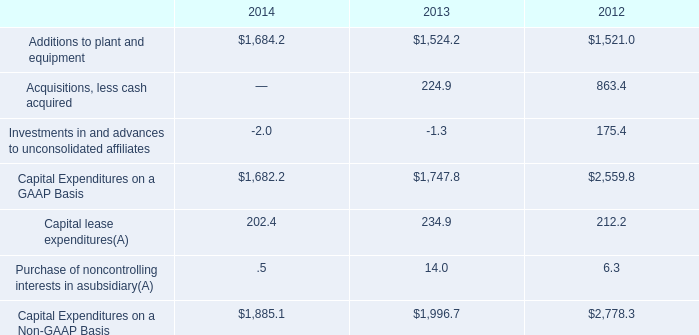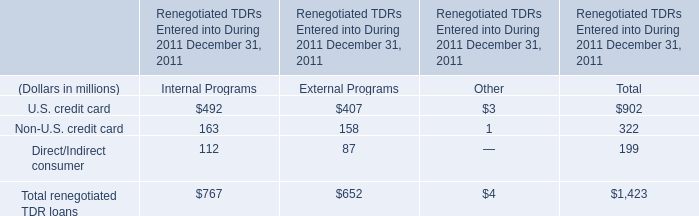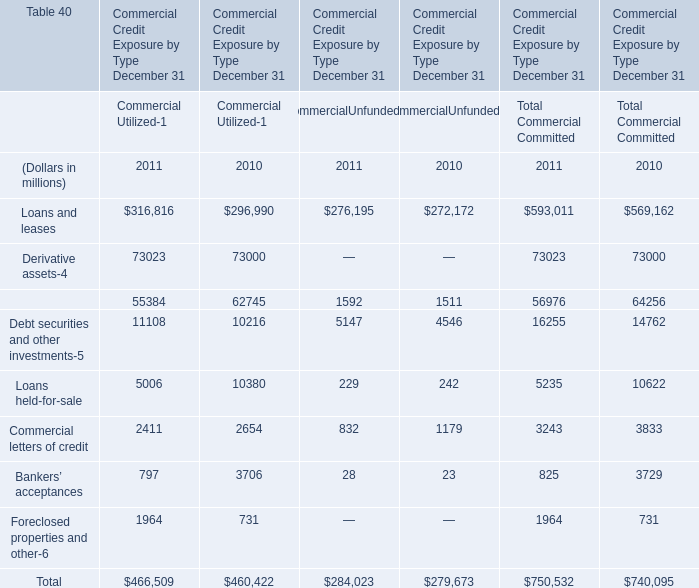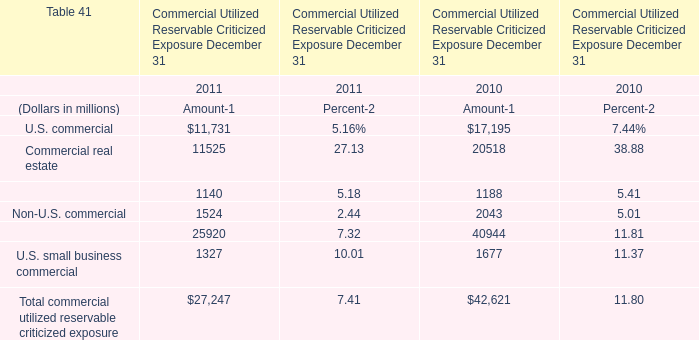What's the current growth rate of Loans and leases? (in %) 
Computations: ((593011 - 569162) / 569162)
Answer: 0.0419. 